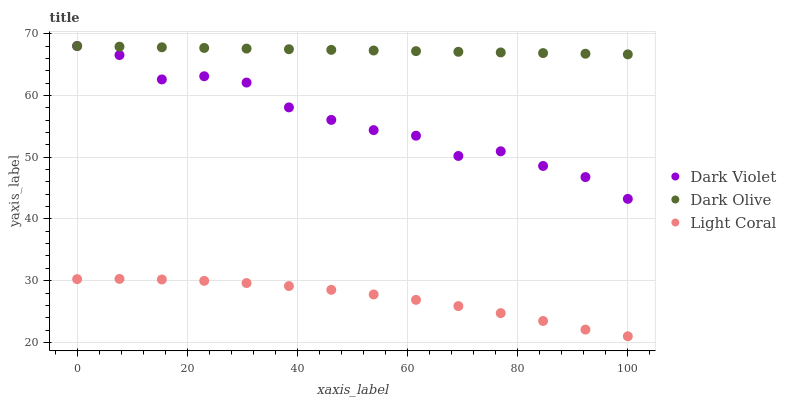Does Light Coral have the minimum area under the curve?
Answer yes or no. Yes. Does Dark Olive have the maximum area under the curve?
Answer yes or no. Yes. Does Dark Violet have the minimum area under the curve?
Answer yes or no. No. Does Dark Violet have the maximum area under the curve?
Answer yes or no. No. Is Dark Olive the smoothest?
Answer yes or no. Yes. Is Dark Violet the roughest?
Answer yes or no. Yes. Is Dark Violet the smoothest?
Answer yes or no. No. Is Dark Olive the roughest?
Answer yes or no. No. Does Light Coral have the lowest value?
Answer yes or no. Yes. Does Dark Violet have the lowest value?
Answer yes or no. No. Does Dark Violet have the highest value?
Answer yes or no. Yes. Is Light Coral less than Dark Violet?
Answer yes or no. Yes. Is Dark Violet greater than Light Coral?
Answer yes or no. Yes. Does Dark Olive intersect Dark Violet?
Answer yes or no. Yes. Is Dark Olive less than Dark Violet?
Answer yes or no. No. Is Dark Olive greater than Dark Violet?
Answer yes or no. No. Does Light Coral intersect Dark Violet?
Answer yes or no. No. 